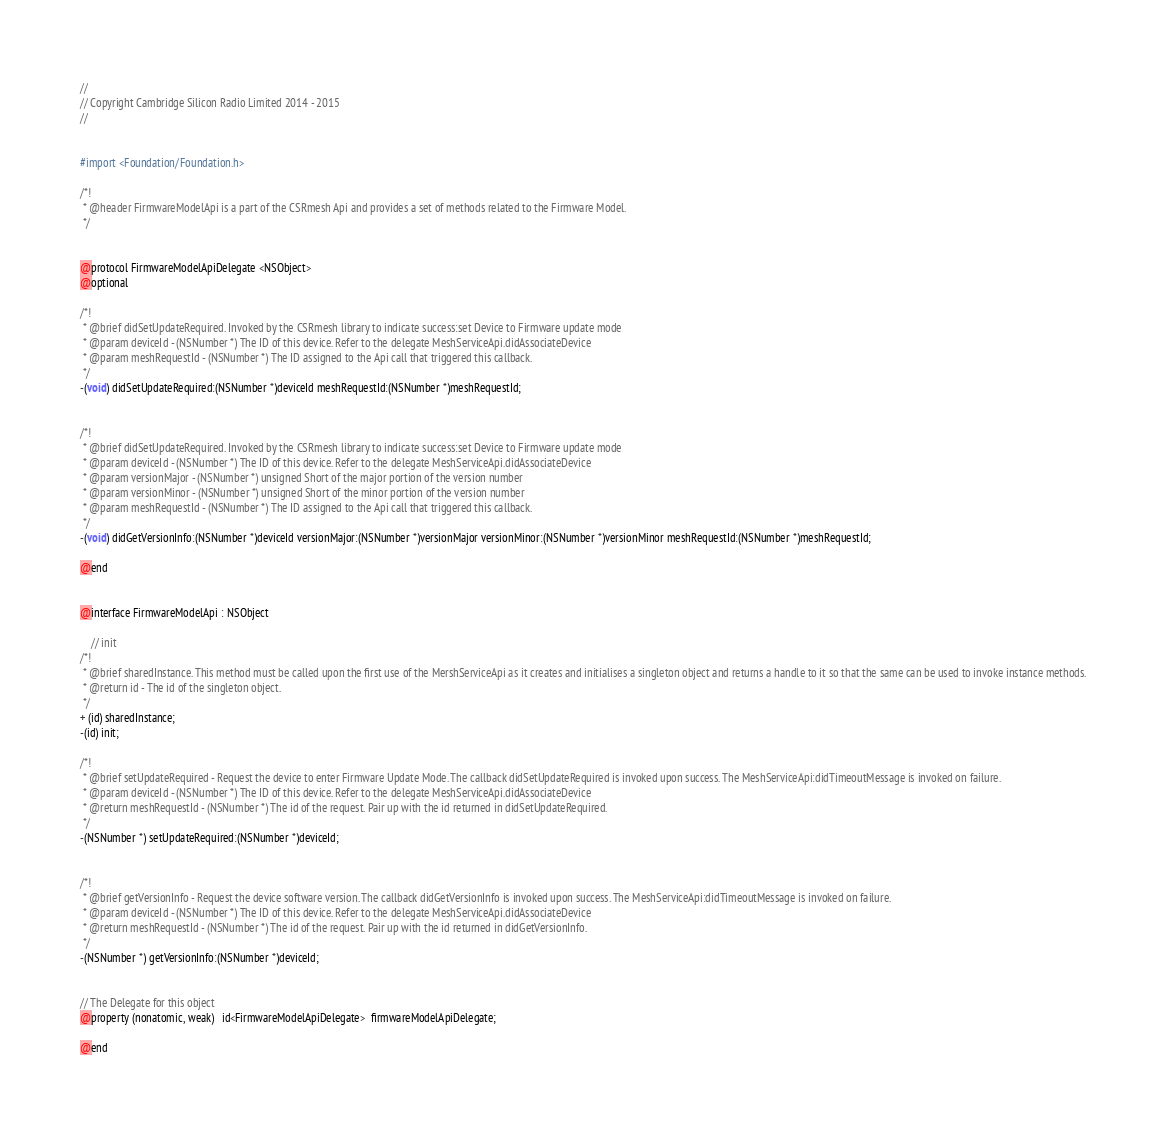Convert code to text. <code><loc_0><loc_0><loc_500><loc_500><_C_>//
// Copyright Cambridge Silicon Radio Limited 2014 - 2015
//


#import <Foundation/Foundation.h>

/*!
 * @header FirmwareModelApi is a part of the CSRmesh Api and provides a set of methods related to the Firmware Model.
 */


@protocol FirmwareModelApiDelegate <NSObject>
@optional

/*!
 * @brief didSetUpdateRequired. Invoked by the CSRmesh library to indicate success:set Device to Firmware update mode
 * @param deviceId - (NSNumber *) The ID of this device. Refer to the delegate MeshServiceApi.didAssociateDevice
 * @param meshRequestId - (NSNumber *) The ID assigned to the Api call that triggered this callback.
 */
-(void) didSetUpdateRequired:(NSNumber *)deviceId meshRequestId:(NSNumber *)meshRequestId;


/*!
 * @brief didSetUpdateRequired. Invoked by the CSRmesh library to indicate success:set Device to Firmware update mode
 * @param deviceId - (NSNumber *) The ID of this device. Refer to the delegate MeshServiceApi.didAssociateDevice
 * @param versionMajor - (NSNumber *) unsigned Short of the major portion of the version number
 * @param versionMinor - (NSNumber *) unsigned Short of the minor portion of the version number
 * @param meshRequestId - (NSNumber *) The ID assigned to the Api call that triggered this callback.
 */
-(void) didGetVersionInfo:(NSNumber *)deviceId versionMajor:(NSNumber *)versionMajor versionMinor:(NSNumber *)versionMinor meshRequestId:(NSNumber *)meshRequestId;

@end


@interface FirmwareModelApi : NSObject

    // init
/*!
 * @brief sharedInstance. This method must be called upon the first use of the MershServiceApi as it creates and initialises a singleton object and returns a handle to it so that the same can be used to invoke instance methods.
 * @return id - The id of the singleton object.
 */
+ (id) sharedInstance;
-(id) init;

/*!
 * @brief setUpdateRequired - Request the device to enter Firmware Update Mode. The callback didSetUpdateRequired is invoked upon success. The MeshServiceApi:didTimeoutMessage is invoked on failure.
 * @param deviceId - (NSNumber *) The ID of this device. Refer to the delegate MeshServiceApi.didAssociateDevice
 * @return meshRequestId - (NSNumber *) The id of the request. Pair up with the id returned in didSetUpdateRequired.
 */
-(NSNumber *) setUpdateRequired:(NSNumber *)deviceId;


/*!
 * @brief getVersionInfo - Request the device software version. The callback didGetVersionInfo is invoked upon success. The MeshServiceApi:didTimeoutMessage is invoked on failure.
 * @param deviceId - (NSNumber *) The ID of this device. Refer to the delegate MeshServiceApi.didAssociateDevice
 * @return meshRequestId - (NSNumber *) The id of the request. Pair up with the id returned in didGetVersionInfo.
 */
-(NSNumber *) getVersionInfo:(NSNumber *)deviceId;


// The Delegate for this object
@property (nonatomic, weak)   id<FirmwareModelApiDelegate>  firmwareModelApiDelegate;

@end
</code> 